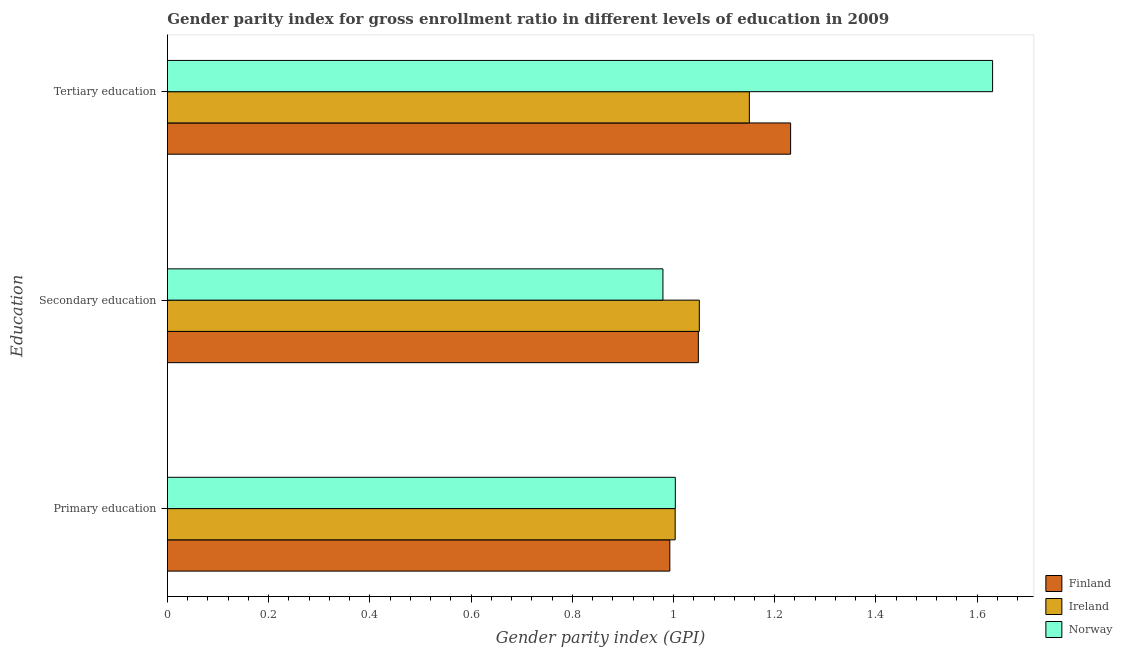How many groups of bars are there?
Your answer should be compact. 3. Are the number of bars per tick equal to the number of legend labels?
Offer a terse response. Yes. How many bars are there on the 3rd tick from the top?
Offer a terse response. 3. What is the label of the 1st group of bars from the top?
Give a very brief answer. Tertiary education. What is the gender parity index in secondary education in Finland?
Offer a very short reply. 1.05. Across all countries, what is the maximum gender parity index in secondary education?
Your answer should be compact. 1.05. Across all countries, what is the minimum gender parity index in secondary education?
Give a very brief answer. 0.98. In which country was the gender parity index in primary education maximum?
Your answer should be compact. Norway. In which country was the gender parity index in secondary education minimum?
Provide a succinct answer. Norway. What is the total gender parity index in tertiary education in the graph?
Your response must be concise. 4.01. What is the difference between the gender parity index in secondary education in Finland and that in Norway?
Ensure brevity in your answer.  0.07. What is the difference between the gender parity index in secondary education in Ireland and the gender parity index in tertiary education in Norway?
Provide a short and direct response. -0.58. What is the average gender parity index in secondary education per country?
Your answer should be very brief. 1.03. What is the difference between the gender parity index in secondary education and gender parity index in tertiary education in Finland?
Your answer should be compact. -0.18. In how many countries, is the gender parity index in primary education greater than 1.4400000000000002 ?
Your answer should be very brief. 0. What is the ratio of the gender parity index in primary education in Ireland to that in Norway?
Provide a succinct answer. 1. Is the difference between the gender parity index in tertiary education in Finland and Ireland greater than the difference between the gender parity index in secondary education in Finland and Ireland?
Provide a succinct answer. Yes. What is the difference between the highest and the second highest gender parity index in tertiary education?
Keep it short and to the point. 0.4. What is the difference between the highest and the lowest gender parity index in primary education?
Your answer should be compact. 0.01. In how many countries, is the gender parity index in secondary education greater than the average gender parity index in secondary education taken over all countries?
Keep it short and to the point. 2. What does the 1st bar from the top in Primary education represents?
Make the answer very short. Norway. How many bars are there?
Your answer should be very brief. 9. How many countries are there in the graph?
Keep it short and to the point. 3. Are the values on the major ticks of X-axis written in scientific E-notation?
Your answer should be compact. No. Does the graph contain any zero values?
Offer a terse response. No. Does the graph contain grids?
Offer a terse response. No. What is the title of the graph?
Provide a short and direct response. Gender parity index for gross enrollment ratio in different levels of education in 2009. What is the label or title of the X-axis?
Offer a terse response. Gender parity index (GPI). What is the label or title of the Y-axis?
Give a very brief answer. Education. What is the Gender parity index (GPI) of Finland in Primary education?
Offer a terse response. 0.99. What is the Gender parity index (GPI) in Ireland in Primary education?
Give a very brief answer. 1. What is the Gender parity index (GPI) of Norway in Primary education?
Give a very brief answer. 1. What is the Gender parity index (GPI) of Finland in Secondary education?
Provide a short and direct response. 1.05. What is the Gender parity index (GPI) of Ireland in Secondary education?
Give a very brief answer. 1.05. What is the Gender parity index (GPI) of Norway in Secondary education?
Provide a succinct answer. 0.98. What is the Gender parity index (GPI) of Finland in Tertiary education?
Keep it short and to the point. 1.23. What is the Gender parity index (GPI) in Ireland in Tertiary education?
Provide a short and direct response. 1.15. What is the Gender parity index (GPI) in Norway in Tertiary education?
Your answer should be very brief. 1.63. Across all Education, what is the maximum Gender parity index (GPI) of Finland?
Offer a terse response. 1.23. Across all Education, what is the maximum Gender parity index (GPI) in Ireland?
Provide a short and direct response. 1.15. Across all Education, what is the maximum Gender parity index (GPI) in Norway?
Give a very brief answer. 1.63. Across all Education, what is the minimum Gender parity index (GPI) in Finland?
Ensure brevity in your answer.  0.99. Across all Education, what is the minimum Gender parity index (GPI) of Ireland?
Ensure brevity in your answer.  1. Across all Education, what is the minimum Gender parity index (GPI) in Norway?
Ensure brevity in your answer.  0.98. What is the total Gender parity index (GPI) of Finland in the graph?
Offer a very short reply. 3.27. What is the total Gender parity index (GPI) in Ireland in the graph?
Your answer should be compact. 3.2. What is the total Gender parity index (GPI) in Norway in the graph?
Make the answer very short. 3.61. What is the difference between the Gender parity index (GPI) of Finland in Primary education and that in Secondary education?
Make the answer very short. -0.06. What is the difference between the Gender parity index (GPI) of Ireland in Primary education and that in Secondary education?
Provide a succinct answer. -0.05. What is the difference between the Gender parity index (GPI) of Norway in Primary education and that in Secondary education?
Make the answer very short. 0.02. What is the difference between the Gender parity index (GPI) in Finland in Primary education and that in Tertiary education?
Provide a short and direct response. -0.24. What is the difference between the Gender parity index (GPI) in Ireland in Primary education and that in Tertiary education?
Provide a short and direct response. -0.15. What is the difference between the Gender parity index (GPI) in Norway in Primary education and that in Tertiary education?
Offer a terse response. -0.63. What is the difference between the Gender parity index (GPI) of Finland in Secondary education and that in Tertiary education?
Provide a short and direct response. -0.18. What is the difference between the Gender parity index (GPI) of Ireland in Secondary education and that in Tertiary education?
Provide a succinct answer. -0.1. What is the difference between the Gender parity index (GPI) of Norway in Secondary education and that in Tertiary education?
Give a very brief answer. -0.65. What is the difference between the Gender parity index (GPI) in Finland in Primary education and the Gender parity index (GPI) in Ireland in Secondary education?
Provide a short and direct response. -0.06. What is the difference between the Gender parity index (GPI) in Finland in Primary education and the Gender parity index (GPI) in Norway in Secondary education?
Your answer should be very brief. 0.01. What is the difference between the Gender parity index (GPI) in Ireland in Primary education and the Gender parity index (GPI) in Norway in Secondary education?
Give a very brief answer. 0.02. What is the difference between the Gender parity index (GPI) in Finland in Primary education and the Gender parity index (GPI) in Ireland in Tertiary education?
Provide a succinct answer. -0.16. What is the difference between the Gender parity index (GPI) in Finland in Primary education and the Gender parity index (GPI) in Norway in Tertiary education?
Offer a very short reply. -0.64. What is the difference between the Gender parity index (GPI) in Ireland in Primary education and the Gender parity index (GPI) in Norway in Tertiary education?
Ensure brevity in your answer.  -0.63. What is the difference between the Gender parity index (GPI) in Finland in Secondary education and the Gender parity index (GPI) in Ireland in Tertiary education?
Your response must be concise. -0.1. What is the difference between the Gender parity index (GPI) of Finland in Secondary education and the Gender parity index (GPI) of Norway in Tertiary education?
Give a very brief answer. -0.58. What is the difference between the Gender parity index (GPI) in Ireland in Secondary education and the Gender parity index (GPI) in Norway in Tertiary education?
Make the answer very short. -0.58. What is the average Gender parity index (GPI) of Finland per Education?
Your answer should be very brief. 1.09. What is the average Gender parity index (GPI) of Ireland per Education?
Your answer should be compact. 1.07. What is the average Gender parity index (GPI) of Norway per Education?
Give a very brief answer. 1.2. What is the difference between the Gender parity index (GPI) of Finland and Gender parity index (GPI) of Ireland in Primary education?
Your response must be concise. -0.01. What is the difference between the Gender parity index (GPI) in Finland and Gender parity index (GPI) in Norway in Primary education?
Give a very brief answer. -0.01. What is the difference between the Gender parity index (GPI) in Ireland and Gender parity index (GPI) in Norway in Primary education?
Keep it short and to the point. -0. What is the difference between the Gender parity index (GPI) in Finland and Gender parity index (GPI) in Ireland in Secondary education?
Your answer should be very brief. -0. What is the difference between the Gender parity index (GPI) of Finland and Gender parity index (GPI) of Norway in Secondary education?
Give a very brief answer. 0.07. What is the difference between the Gender parity index (GPI) of Ireland and Gender parity index (GPI) of Norway in Secondary education?
Offer a terse response. 0.07. What is the difference between the Gender parity index (GPI) of Finland and Gender parity index (GPI) of Ireland in Tertiary education?
Provide a short and direct response. 0.08. What is the difference between the Gender parity index (GPI) of Finland and Gender parity index (GPI) of Norway in Tertiary education?
Make the answer very short. -0.4. What is the difference between the Gender parity index (GPI) in Ireland and Gender parity index (GPI) in Norway in Tertiary education?
Offer a terse response. -0.48. What is the ratio of the Gender parity index (GPI) in Finland in Primary education to that in Secondary education?
Provide a short and direct response. 0.95. What is the ratio of the Gender parity index (GPI) of Ireland in Primary education to that in Secondary education?
Ensure brevity in your answer.  0.95. What is the ratio of the Gender parity index (GPI) in Finland in Primary education to that in Tertiary education?
Offer a terse response. 0.81. What is the ratio of the Gender parity index (GPI) of Ireland in Primary education to that in Tertiary education?
Make the answer very short. 0.87. What is the ratio of the Gender parity index (GPI) in Norway in Primary education to that in Tertiary education?
Offer a very short reply. 0.62. What is the ratio of the Gender parity index (GPI) of Finland in Secondary education to that in Tertiary education?
Your answer should be compact. 0.85. What is the ratio of the Gender parity index (GPI) in Ireland in Secondary education to that in Tertiary education?
Provide a succinct answer. 0.91. What is the ratio of the Gender parity index (GPI) of Norway in Secondary education to that in Tertiary education?
Your answer should be compact. 0.6. What is the difference between the highest and the second highest Gender parity index (GPI) in Finland?
Offer a very short reply. 0.18. What is the difference between the highest and the second highest Gender parity index (GPI) of Ireland?
Your response must be concise. 0.1. What is the difference between the highest and the second highest Gender parity index (GPI) of Norway?
Offer a very short reply. 0.63. What is the difference between the highest and the lowest Gender parity index (GPI) of Finland?
Offer a terse response. 0.24. What is the difference between the highest and the lowest Gender parity index (GPI) of Ireland?
Give a very brief answer. 0.15. What is the difference between the highest and the lowest Gender parity index (GPI) in Norway?
Make the answer very short. 0.65. 